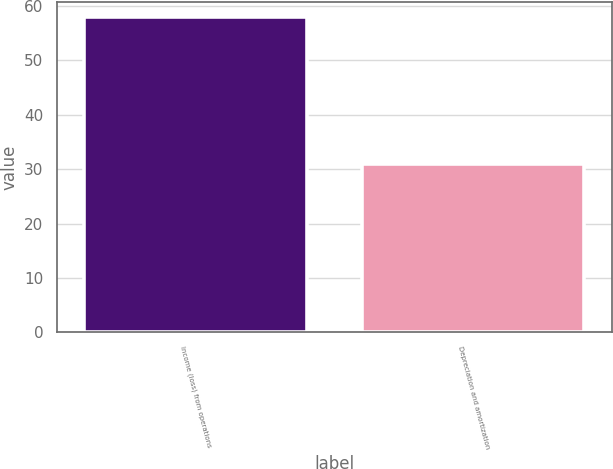Convert chart. <chart><loc_0><loc_0><loc_500><loc_500><bar_chart><fcel>Income (loss) from operations<fcel>Depreciation and amortization<nl><fcel>57.9<fcel>30.9<nl></chart> 